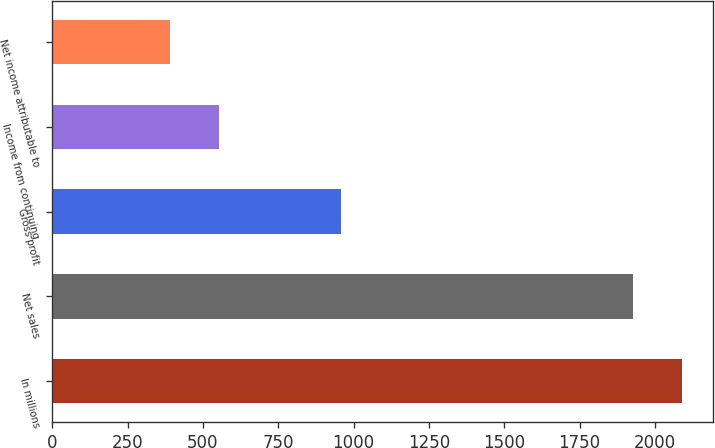Convert chart to OTSL. <chart><loc_0><loc_0><loc_500><loc_500><bar_chart><fcel>In millions<fcel>Net sales<fcel>Gross profit<fcel>Income from continuing<fcel>Net income attributable to<nl><fcel>2089.5<fcel>1927<fcel>957<fcel>553.5<fcel>391<nl></chart> 